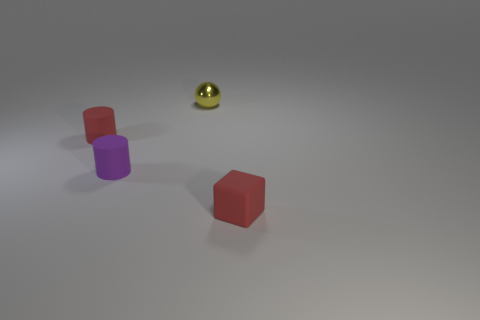What size is the object that is to the right of the purple cylinder and behind the purple matte thing?
Make the answer very short. Small. How many big yellow objects are there?
Your answer should be very brief. 0. What material is the purple cylinder that is the same size as the red cube?
Your answer should be compact. Rubber. Is there a sphere that has the same size as the yellow shiny thing?
Offer a terse response. No. Do the tiny object that is behind the tiny red cylinder and the rubber cylinder in front of the red rubber cylinder have the same color?
Offer a terse response. No. How many rubber objects are tiny red things or big balls?
Give a very brief answer. 2. There is a red rubber object that is behind the red thing in front of the red matte cylinder; how many blocks are on the right side of it?
Offer a terse response. 1. There is a purple cylinder that is the same material as the red block; what is its size?
Provide a short and direct response. Small. How many other balls have the same color as the metallic sphere?
Keep it short and to the point. 0. There is a red matte thing behind the block; is its size the same as the purple matte object?
Your answer should be compact. Yes. 